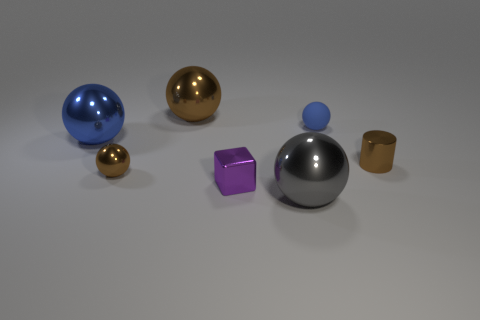Are there any other things that have the same material as the small blue ball?
Your answer should be compact. No. Does the small sphere that is behind the large blue shiny thing have the same color as the large object behind the tiny blue thing?
Provide a short and direct response. No. How many shiny objects are tiny objects or cubes?
Provide a short and direct response. 3. Is there any other thing that is the same size as the block?
Your answer should be compact. Yes. What is the shape of the small brown thing that is on the right side of the big sphere that is in front of the tiny brown cylinder?
Keep it short and to the point. Cylinder. Does the blue object that is to the right of the purple shiny thing have the same material as the large thing that is behind the blue matte ball?
Provide a short and direct response. No. There is a large sphere in front of the metal cylinder; what number of brown objects are left of it?
Give a very brief answer. 2. There is a tiny metallic thing right of the small rubber object; is it the same shape as the large thing left of the small brown sphere?
Keep it short and to the point. No. There is a brown thing that is both in front of the large brown shiny ball and to the left of the matte thing; what size is it?
Ensure brevity in your answer.  Small. What is the color of the other tiny rubber thing that is the same shape as the gray thing?
Offer a very short reply. Blue. 